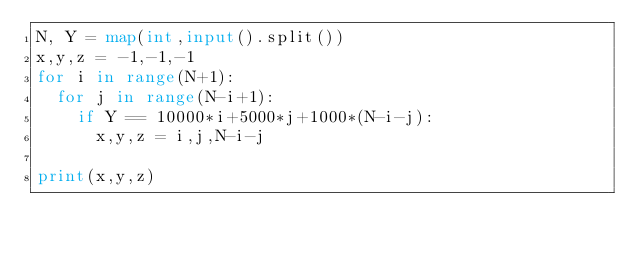<code> <loc_0><loc_0><loc_500><loc_500><_Python_>N, Y = map(int,input().split())
x,y,z = -1,-1,-1
for i in range(N+1):
  for j in range(N-i+1):
    if Y == 10000*i+5000*j+1000*(N-i-j):
      x,y,z = i,j,N-i-j
 
print(x,y,z)</code> 